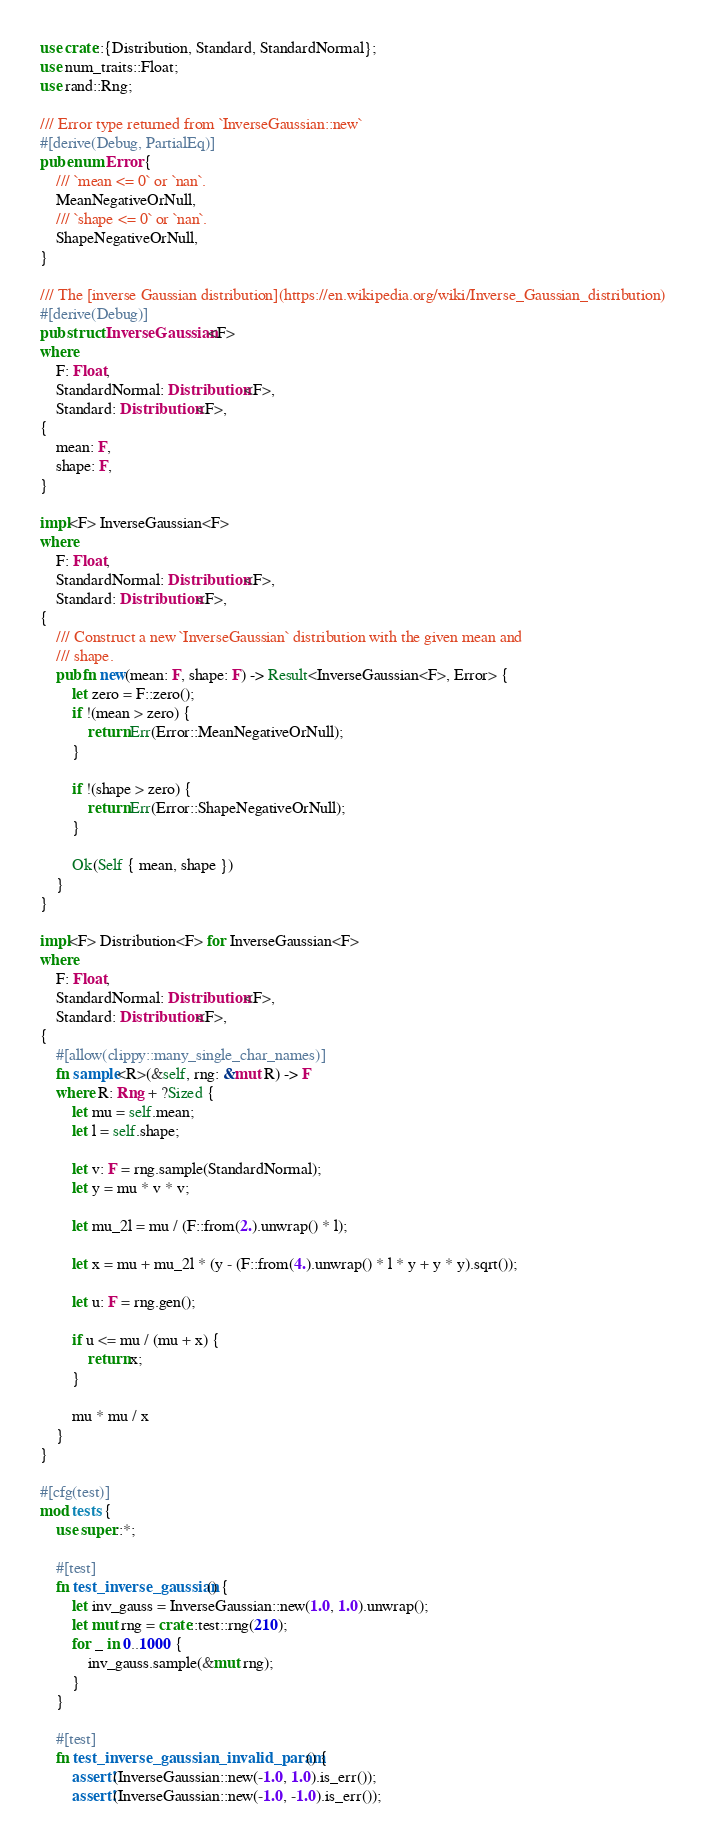Convert code to text. <code><loc_0><loc_0><loc_500><loc_500><_Rust_>use crate::{Distribution, Standard, StandardNormal};
use num_traits::Float;
use rand::Rng;

/// Error type returned from `InverseGaussian::new`
#[derive(Debug, PartialEq)]
pub enum Error {
    /// `mean <= 0` or `nan`.
    MeanNegativeOrNull,
    /// `shape <= 0` or `nan`.
    ShapeNegativeOrNull,
}

/// The [inverse Gaussian distribution](https://en.wikipedia.org/wiki/Inverse_Gaussian_distribution)
#[derive(Debug)]
pub struct InverseGaussian<F>
where
    F: Float,
    StandardNormal: Distribution<F>,
    Standard: Distribution<F>,
{
    mean: F,
    shape: F,
}

impl<F> InverseGaussian<F>
where
    F: Float,
    StandardNormal: Distribution<F>,
    Standard: Distribution<F>,
{
    /// Construct a new `InverseGaussian` distribution with the given mean and
    /// shape.
    pub fn new(mean: F, shape: F) -> Result<InverseGaussian<F>, Error> {
        let zero = F::zero();
        if !(mean > zero) {
            return Err(Error::MeanNegativeOrNull);
        }

        if !(shape > zero) {
            return Err(Error::ShapeNegativeOrNull);
        }

        Ok(Self { mean, shape })
    }
}

impl<F> Distribution<F> for InverseGaussian<F>
where
    F: Float,
    StandardNormal: Distribution<F>,
    Standard: Distribution<F>,
{
    #[allow(clippy::many_single_char_names)]
    fn sample<R>(&self, rng: &mut R) -> F
    where R: Rng + ?Sized {
        let mu = self.mean;
        let l = self.shape;

        let v: F = rng.sample(StandardNormal);
        let y = mu * v * v;

        let mu_2l = mu / (F::from(2.).unwrap() * l);

        let x = mu + mu_2l * (y - (F::from(4.).unwrap() * l * y + y * y).sqrt());

        let u: F = rng.gen();

        if u <= mu / (mu + x) {
            return x;
        }

        mu * mu / x
    }
}

#[cfg(test)]
mod tests {
    use super::*;

    #[test]
    fn test_inverse_gaussian() {
        let inv_gauss = InverseGaussian::new(1.0, 1.0).unwrap();
        let mut rng = crate::test::rng(210);
        for _ in 0..1000 {
            inv_gauss.sample(&mut rng);
        }
    }

    #[test]
    fn test_inverse_gaussian_invalid_param() {
        assert!(InverseGaussian::new(-1.0, 1.0).is_err());
        assert!(InverseGaussian::new(-1.0, -1.0).is_err());</code> 